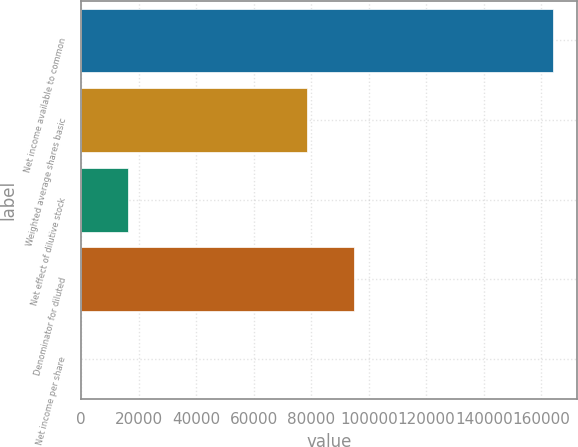<chart> <loc_0><loc_0><loc_500><loc_500><bar_chart><fcel>Net income available to common<fcel>Weighted average shares basic<fcel>Net effect of dilutive stock<fcel>Denominator for diluted<fcel>Net income per share<nl><fcel>164061<fcel>78403<fcel>16408<fcel>94808.9<fcel>2.09<nl></chart> 